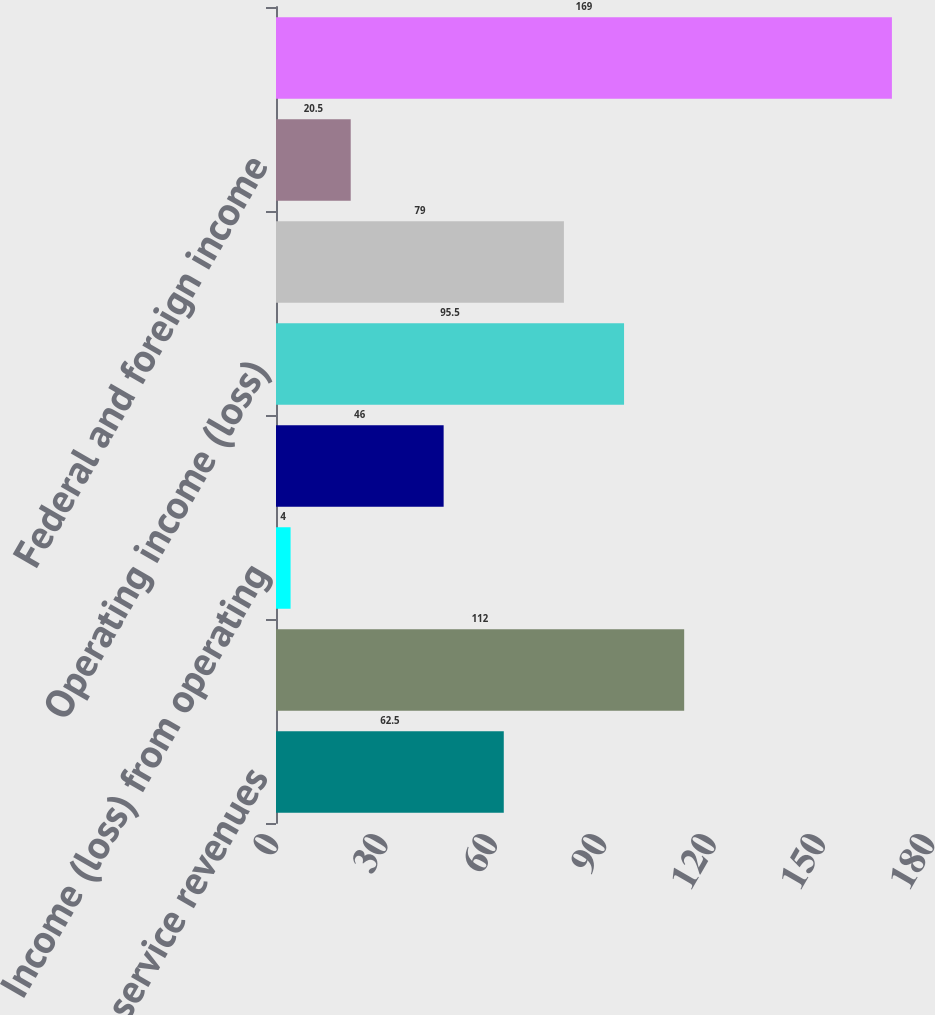Convert chart. <chart><loc_0><loc_0><loc_500><loc_500><bar_chart><fcel>Sales and service revenues<fcel>Cost of product sales and<fcel>Income (loss) from operating<fcel>General and administrative<fcel>Operating income (loss)<fcel>Interest expense<fcel>Federal and foreign income<fcel>Net earnings (loss)<nl><fcel>62.5<fcel>112<fcel>4<fcel>46<fcel>95.5<fcel>79<fcel>20.5<fcel>169<nl></chart> 